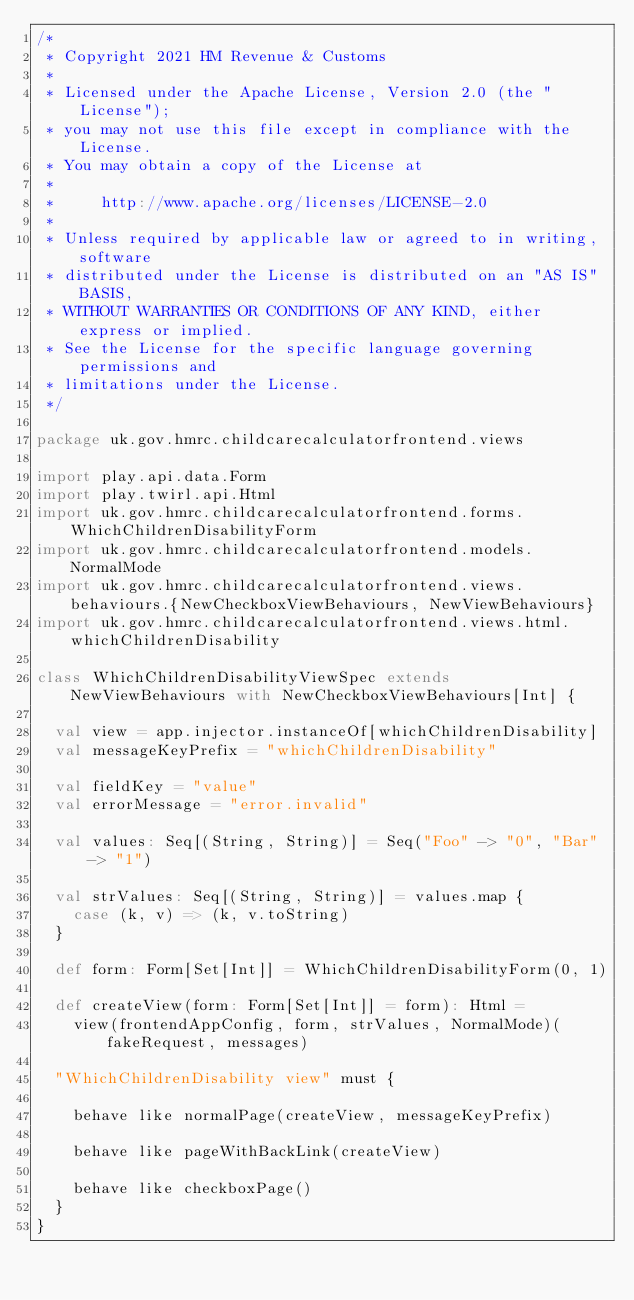Convert code to text. <code><loc_0><loc_0><loc_500><loc_500><_Scala_>/*
 * Copyright 2021 HM Revenue & Customs
 *
 * Licensed under the Apache License, Version 2.0 (the "License");
 * you may not use this file except in compliance with the License.
 * You may obtain a copy of the License at
 *
 *     http://www.apache.org/licenses/LICENSE-2.0
 *
 * Unless required by applicable law or agreed to in writing, software
 * distributed under the License is distributed on an "AS IS" BASIS,
 * WITHOUT WARRANTIES OR CONDITIONS OF ANY KIND, either express or implied.
 * See the License for the specific language governing permissions and
 * limitations under the License.
 */

package uk.gov.hmrc.childcarecalculatorfrontend.views

import play.api.data.Form
import play.twirl.api.Html
import uk.gov.hmrc.childcarecalculatorfrontend.forms.WhichChildrenDisabilityForm
import uk.gov.hmrc.childcarecalculatorfrontend.models.NormalMode
import uk.gov.hmrc.childcarecalculatorfrontend.views.behaviours.{NewCheckboxViewBehaviours, NewViewBehaviours}
import uk.gov.hmrc.childcarecalculatorfrontend.views.html.whichChildrenDisability

class WhichChildrenDisabilityViewSpec extends NewViewBehaviours with NewCheckboxViewBehaviours[Int] {

  val view = app.injector.instanceOf[whichChildrenDisability]
  val messageKeyPrefix = "whichChildrenDisability"

  val fieldKey = "value"
  val errorMessage = "error.invalid"

  val values: Seq[(String, String)] = Seq("Foo" -> "0", "Bar" -> "1")

  val strValues: Seq[(String, String)] = values.map {
    case (k, v) => (k, v.toString)
  }

  def form: Form[Set[Int]] = WhichChildrenDisabilityForm(0, 1)

  def createView(form: Form[Set[Int]] = form): Html =
    view(frontendAppConfig, form, strValues, NormalMode)(fakeRequest, messages)

  "WhichChildrenDisability view" must {

    behave like normalPage(createView, messageKeyPrefix)

    behave like pageWithBackLink(createView)

    behave like checkboxPage()
  }
}
</code> 